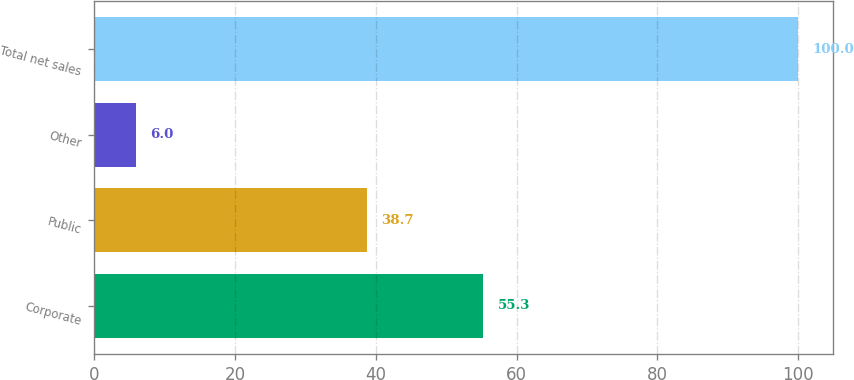Convert chart. <chart><loc_0><loc_0><loc_500><loc_500><bar_chart><fcel>Corporate<fcel>Public<fcel>Other<fcel>Total net sales<nl><fcel>55.3<fcel>38.7<fcel>6<fcel>100<nl></chart> 